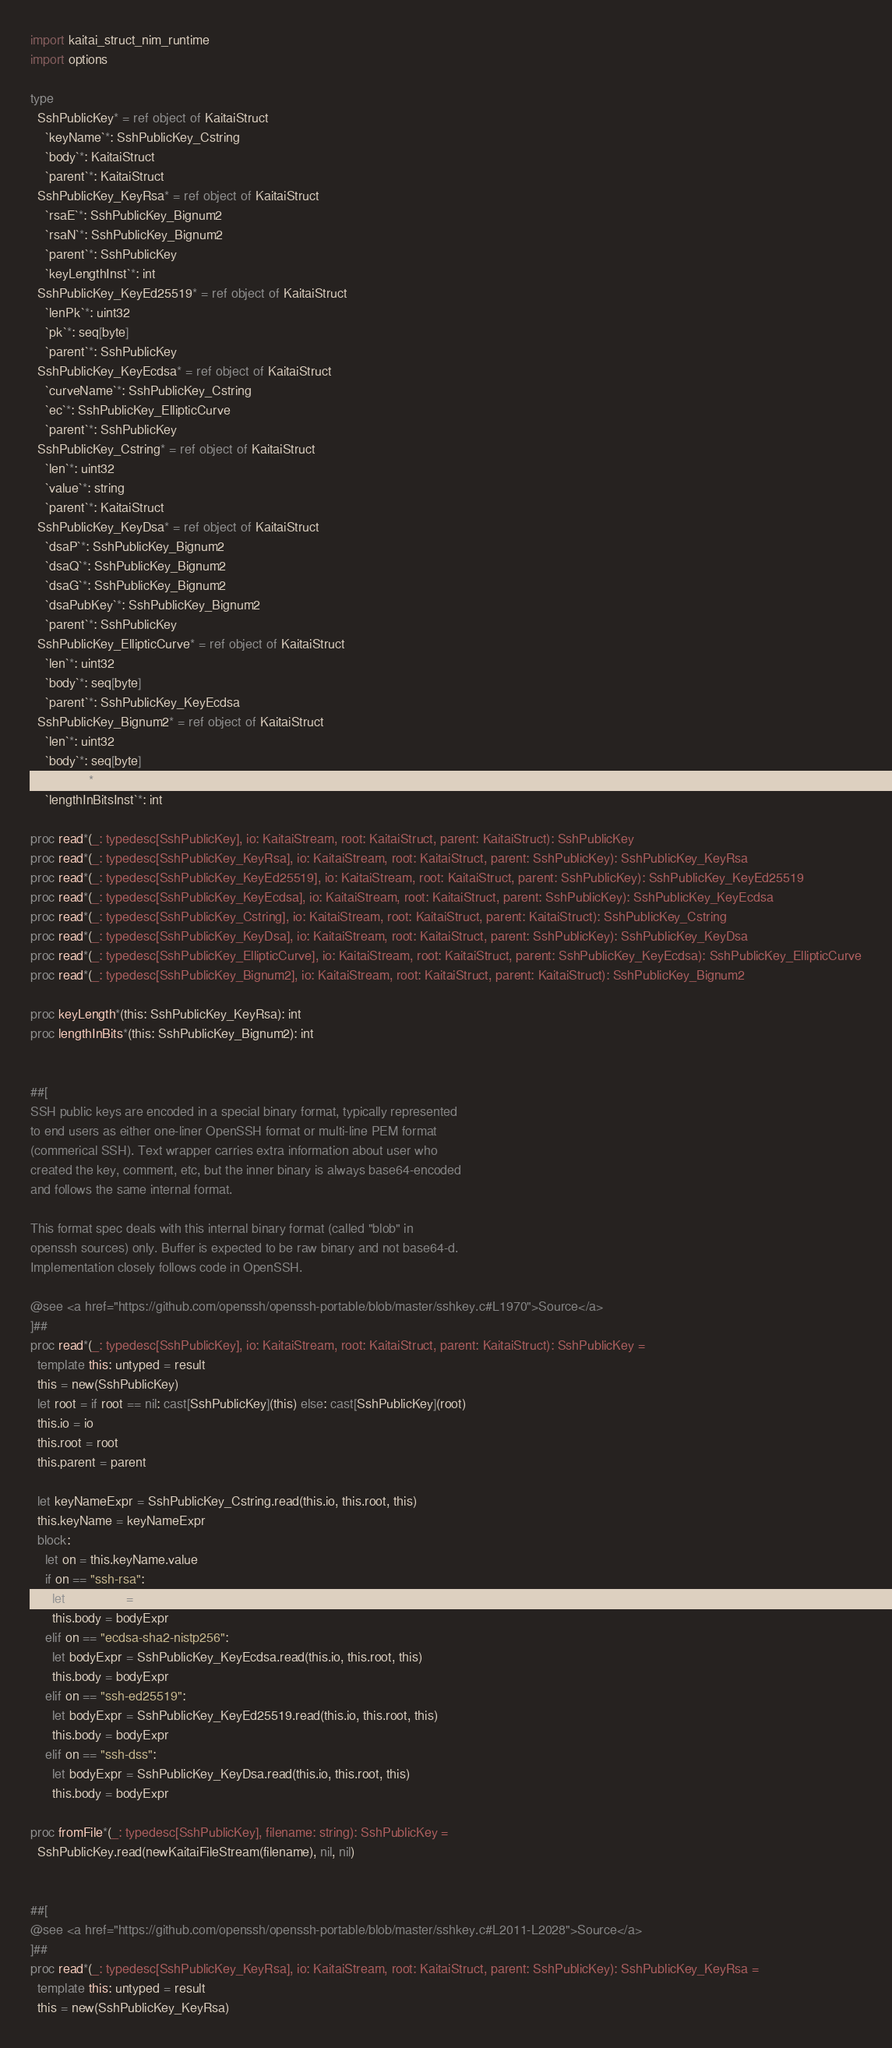<code> <loc_0><loc_0><loc_500><loc_500><_Nim_>import kaitai_struct_nim_runtime
import options

type
  SshPublicKey* = ref object of KaitaiStruct
    `keyName`*: SshPublicKey_Cstring
    `body`*: KaitaiStruct
    `parent`*: KaitaiStruct
  SshPublicKey_KeyRsa* = ref object of KaitaiStruct
    `rsaE`*: SshPublicKey_Bignum2
    `rsaN`*: SshPublicKey_Bignum2
    `parent`*: SshPublicKey
    `keyLengthInst`*: int
  SshPublicKey_KeyEd25519* = ref object of KaitaiStruct
    `lenPk`*: uint32
    `pk`*: seq[byte]
    `parent`*: SshPublicKey
  SshPublicKey_KeyEcdsa* = ref object of KaitaiStruct
    `curveName`*: SshPublicKey_Cstring
    `ec`*: SshPublicKey_EllipticCurve
    `parent`*: SshPublicKey
  SshPublicKey_Cstring* = ref object of KaitaiStruct
    `len`*: uint32
    `value`*: string
    `parent`*: KaitaiStruct
  SshPublicKey_KeyDsa* = ref object of KaitaiStruct
    `dsaP`*: SshPublicKey_Bignum2
    `dsaQ`*: SshPublicKey_Bignum2
    `dsaG`*: SshPublicKey_Bignum2
    `dsaPubKey`*: SshPublicKey_Bignum2
    `parent`*: SshPublicKey
  SshPublicKey_EllipticCurve* = ref object of KaitaiStruct
    `len`*: uint32
    `body`*: seq[byte]
    `parent`*: SshPublicKey_KeyEcdsa
  SshPublicKey_Bignum2* = ref object of KaitaiStruct
    `len`*: uint32
    `body`*: seq[byte]
    `parent`*: KaitaiStruct
    `lengthInBitsInst`*: int

proc read*(_: typedesc[SshPublicKey], io: KaitaiStream, root: KaitaiStruct, parent: KaitaiStruct): SshPublicKey
proc read*(_: typedesc[SshPublicKey_KeyRsa], io: KaitaiStream, root: KaitaiStruct, parent: SshPublicKey): SshPublicKey_KeyRsa
proc read*(_: typedesc[SshPublicKey_KeyEd25519], io: KaitaiStream, root: KaitaiStruct, parent: SshPublicKey): SshPublicKey_KeyEd25519
proc read*(_: typedesc[SshPublicKey_KeyEcdsa], io: KaitaiStream, root: KaitaiStruct, parent: SshPublicKey): SshPublicKey_KeyEcdsa
proc read*(_: typedesc[SshPublicKey_Cstring], io: KaitaiStream, root: KaitaiStruct, parent: KaitaiStruct): SshPublicKey_Cstring
proc read*(_: typedesc[SshPublicKey_KeyDsa], io: KaitaiStream, root: KaitaiStruct, parent: SshPublicKey): SshPublicKey_KeyDsa
proc read*(_: typedesc[SshPublicKey_EllipticCurve], io: KaitaiStream, root: KaitaiStruct, parent: SshPublicKey_KeyEcdsa): SshPublicKey_EllipticCurve
proc read*(_: typedesc[SshPublicKey_Bignum2], io: KaitaiStream, root: KaitaiStruct, parent: KaitaiStruct): SshPublicKey_Bignum2

proc keyLength*(this: SshPublicKey_KeyRsa): int
proc lengthInBits*(this: SshPublicKey_Bignum2): int


##[
SSH public keys are encoded in a special binary format, typically represented
to end users as either one-liner OpenSSH format or multi-line PEM format
(commerical SSH). Text wrapper carries extra information about user who
created the key, comment, etc, but the inner binary is always base64-encoded
and follows the same internal format.

This format spec deals with this internal binary format (called "blob" in
openssh sources) only. Buffer is expected to be raw binary and not base64-d.
Implementation closely follows code in OpenSSH.

@see <a href="https://github.com/openssh/openssh-portable/blob/master/sshkey.c#L1970">Source</a>
]##
proc read*(_: typedesc[SshPublicKey], io: KaitaiStream, root: KaitaiStruct, parent: KaitaiStruct): SshPublicKey =
  template this: untyped = result
  this = new(SshPublicKey)
  let root = if root == nil: cast[SshPublicKey](this) else: cast[SshPublicKey](root)
  this.io = io
  this.root = root
  this.parent = parent

  let keyNameExpr = SshPublicKey_Cstring.read(this.io, this.root, this)
  this.keyName = keyNameExpr
  block:
    let on = this.keyName.value
    if on == "ssh-rsa":
      let bodyExpr = SshPublicKey_KeyRsa.read(this.io, this.root, this)
      this.body = bodyExpr
    elif on == "ecdsa-sha2-nistp256":
      let bodyExpr = SshPublicKey_KeyEcdsa.read(this.io, this.root, this)
      this.body = bodyExpr
    elif on == "ssh-ed25519":
      let bodyExpr = SshPublicKey_KeyEd25519.read(this.io, this.root, this)
      this.body = bodyExpr
    elif on == "ssh-dss":
      let bodyExpr = SshPublicKey_KeyDsa.read(this.io, this.root, this)
      this.body = bodyExpr

proc fromFile*(_: typedesc[SshPublicKey], filename: string): SshPublicKey =
  SshPublicKey.read(newKaitaiFileStream(filename), nil, nil)


##[
@see <a href="https://github.com/openssh/openssh-portable/blob/master/sshkey.c#L2011-L2028">Source</a>
]##
proc read*(_: typedesc[SshPublicKey_KeyRsa], io: KaitaiStream, root: KaitaiStruct, parent: SshPublicKey): SshPublicKey_KeyRsa =
  template this: untyped = result
  this = new(SshPublicKey_KeyRsa)</code> 